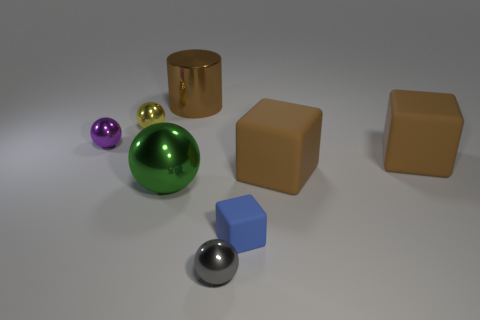Are there fewer cyan cylinders than tiny spheres?
Provide a succinct answer. Yes. Are there any large red cylinders that have the same material as the big green object?
Provide a succinct answer. No. There is a brown thing that is to the left of the gray shiny object; what shape is it?
Offer a terse response. Cylinder. Do the sphere that is right of the green thing and the large cylinder have the same color?
Provide a succinct answer. No. Is the number of tiny yellow shiny objects that are behind the large brown metal object less than the number of green metal spheres?
Provide a succinct answer. Yes. The large cylinder that is made of the same material as the gray ball is what color?
Provide a short and direct response. Brown. There is a brown thing that is to the left of the small gray metal thing; how big is it?
Make the answer very short. Large. Are the large cylinder and the small purple ball made of the same material?
Keep it short and to the point. Yes. Is there a small metallic object right of the brown thing that is on the left side of the ball that is in front of the blue rubber block?
Provide a succinct answer. Yes. The cylinder has what color?
Provide a short and direct response. Brown. 